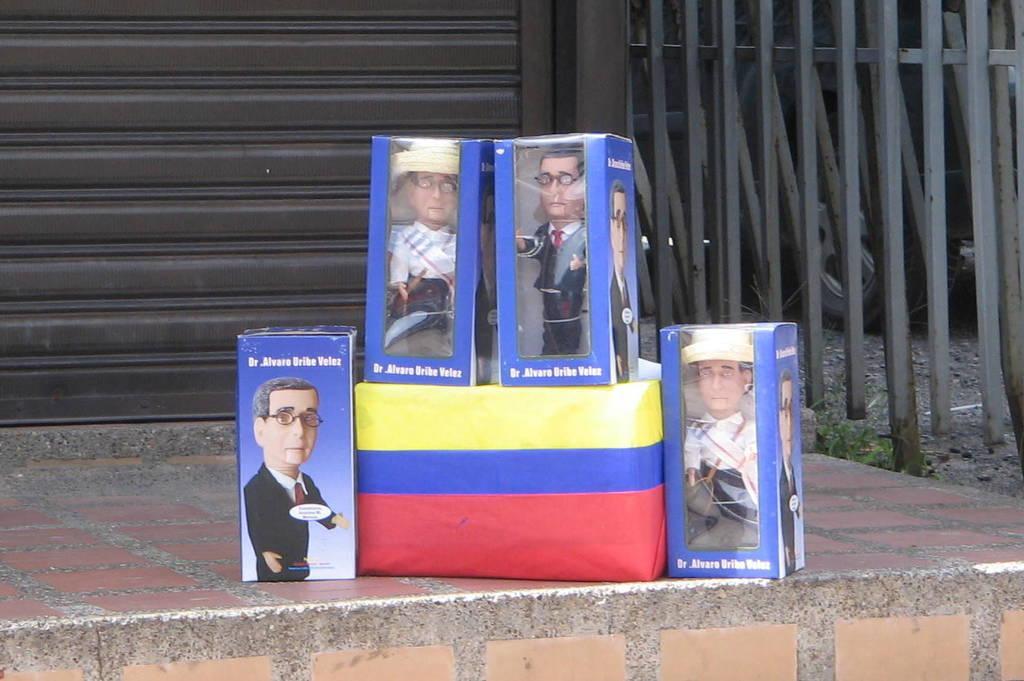Describe this image in one or two sentences. As we can see in the image there is rolling shutter, fence and bag. There are boxes and dolls. 